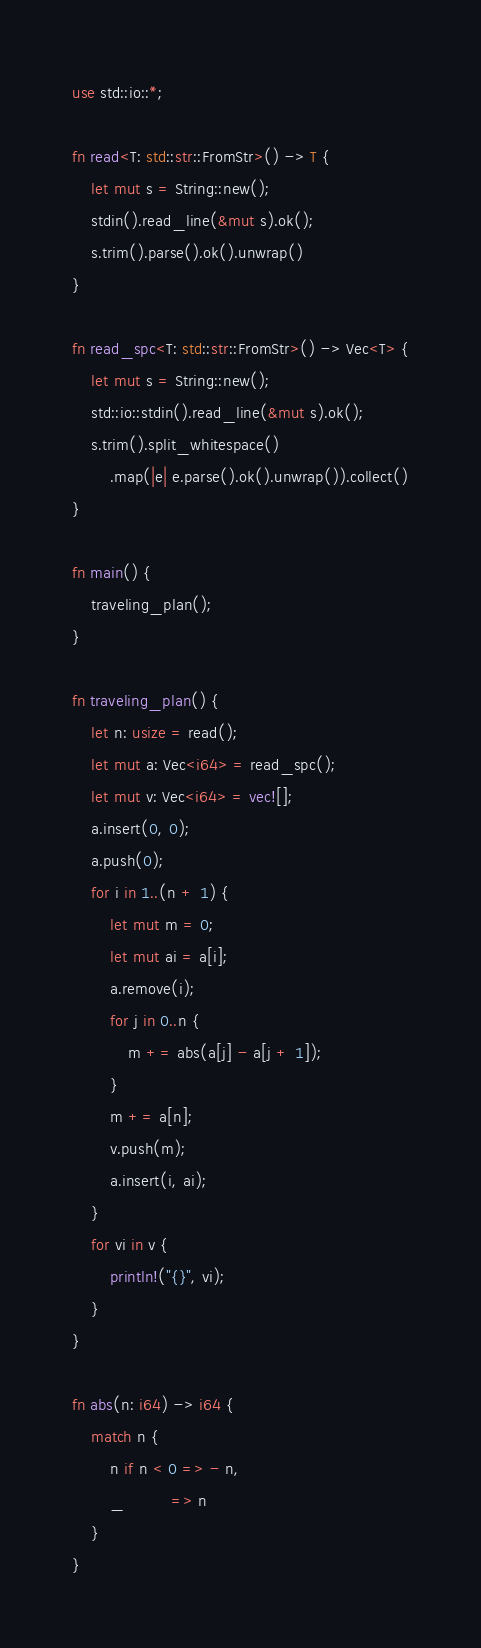Convert code to text. <code><loc_0><loc_0><loc_500><loc_500><_Rust_>use std::io::*;

fn read<T: std::str::FromStr>() -> T {
    let mut s = String::new();
    stdin().read_line(&mut s).ok();
    s.trim().parse().ok().unwrap()
}

fn read_spc<T: std::str::FromStr>() -> Vec<T> {
    let mut s = String::new();
    std::io::stdin().read_line(&mut s).ok();
    s.trim().split_whitespace()
        .map(|e| e.parse().ok().unwrap()).collect()
}

fn main() {
    traveling_plan();
}

fn traveling_plan() {
    let n: usize = read();
    let mut a: Vec<i64> = read_spc();
    let mut v: Vec<i64> = vec![];
    a.insert(0, 0);
    a.push(0);
    for i in 1..(n + 1) {
        let mut m = 0;
        let mut ai = a[i];
        a.remove(i);
        for j in 0..n {
            m += abs(a[j] - a[j + 1]);
        }
        m += a[n];
        v.push(m);
        a.insert(i, ai);
    }
    for vi in v {
        println!("{}", vi);
    }
}

fn abs(n: i64) -> i64 {
    match n {
        n if n < 0 => - n,
        _          => n
    }
}</code> 